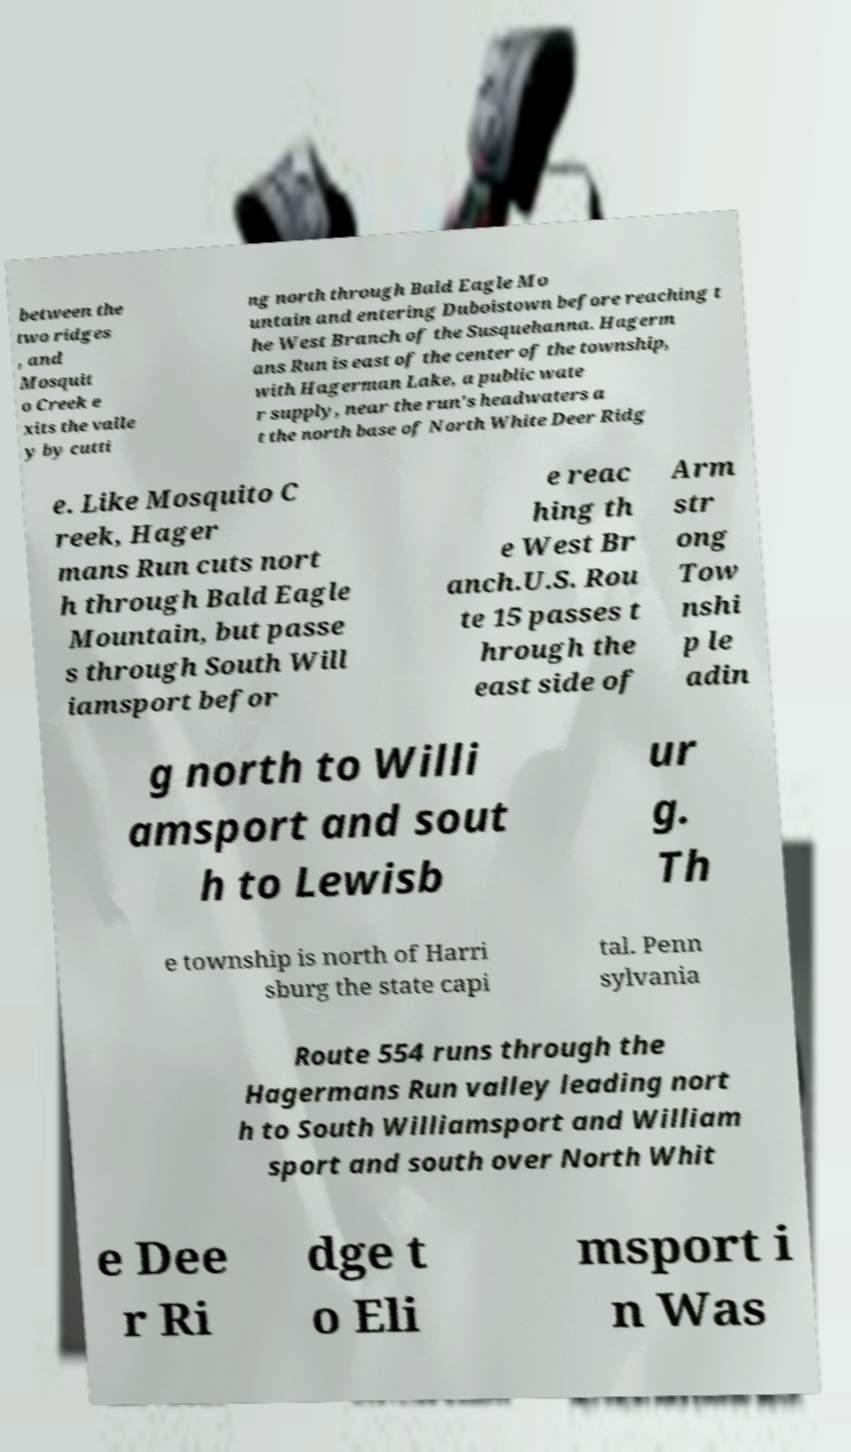Can you accurately transcribe the text from the provided image for me? between the two ridges , and Mosquit o Creek e xits the valle y by cutti ng north through Bald Eagle Mo untain and entering Duboistown before reaching t he West Branch of the Susquehanna. Hagerm ans Run is east of the center of the township, with Hagerman Lake, a public wate r supply, near the run's headwaters a t the north base of North White Deer Ridg e. Like Mosquito C reek, Hager mans Run cuts nort h through Bald Eagle Mountain, but passe s through South Will iamsport befor e reac hing th e West Br anch.U.S. Rou te 15 passes t hrough the east side of Arm str ong Tow nshi p le adin g north to Willi amsport and sout h to Lewisb ur g. Th e township is north of Harri sburg the state capi tal. Penn sylvania Route 554 runs through the Hagermans Run valley leading nort h to South Williamsport and William sport and south over North Whit e Dee r Ri dge t o Eli msport i n Was 